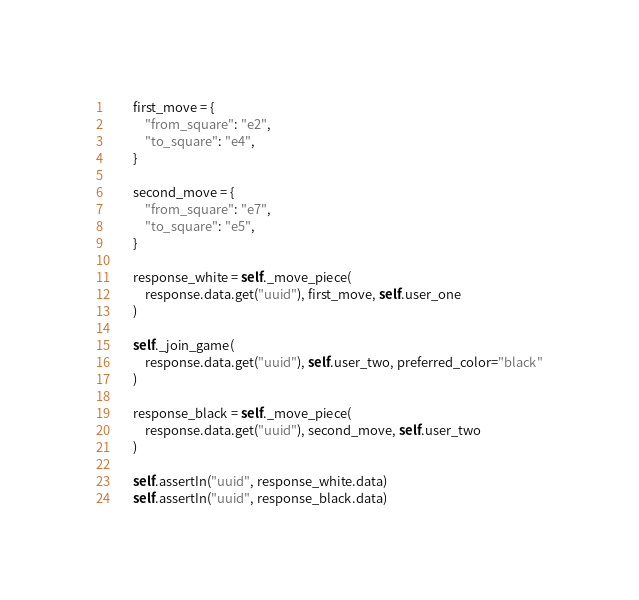Convert code to text. <code><loc_0><loc_0><loc_500><loc_500><_Python_>
        first_move = {
            "from_square": "e2",
            "to_square": "e4",
        }

        second_move = {
            "from_square": "e7",
            "to_square": "e5",
        }

        response_white = self._move_piece(
            response.data.get("uuid"), first_move, self.user_one
        )

        self._join_game(
            response.data.get("uuid"), self.user_two, preferred_color="black"
        )

        response_black = self._move_piece(
            response.data.get("uuid"), second_move, self.user_two
        )

        self.assertIn("uuid", response_white.data)
        self.assertIn("uuid", response_black.data)
</code> 